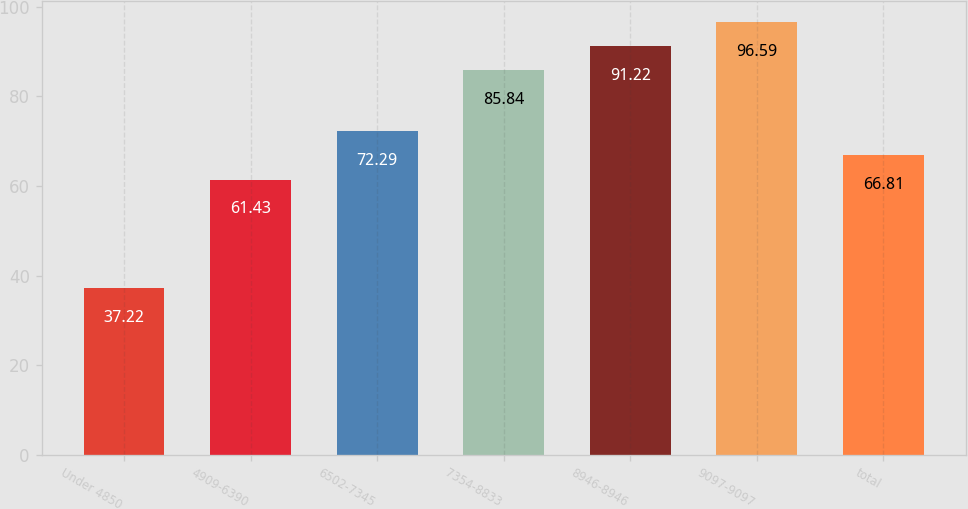Convert chart. <chart><loc_0><loc_0><loc_500><loc_500><bar_chart><fcel>Under 4850<fcel>4909-6390<fcel>6502-7345<fcel>7354-8833<fcel>8946-8946<fcel>9097-9097<fcel>total<nl><fcel>37.22<fcel>61.43<fcel>72.29<fcel>85.84<fcel>91.22<fcel>96.59<fcel>66.81<nl></chart> 